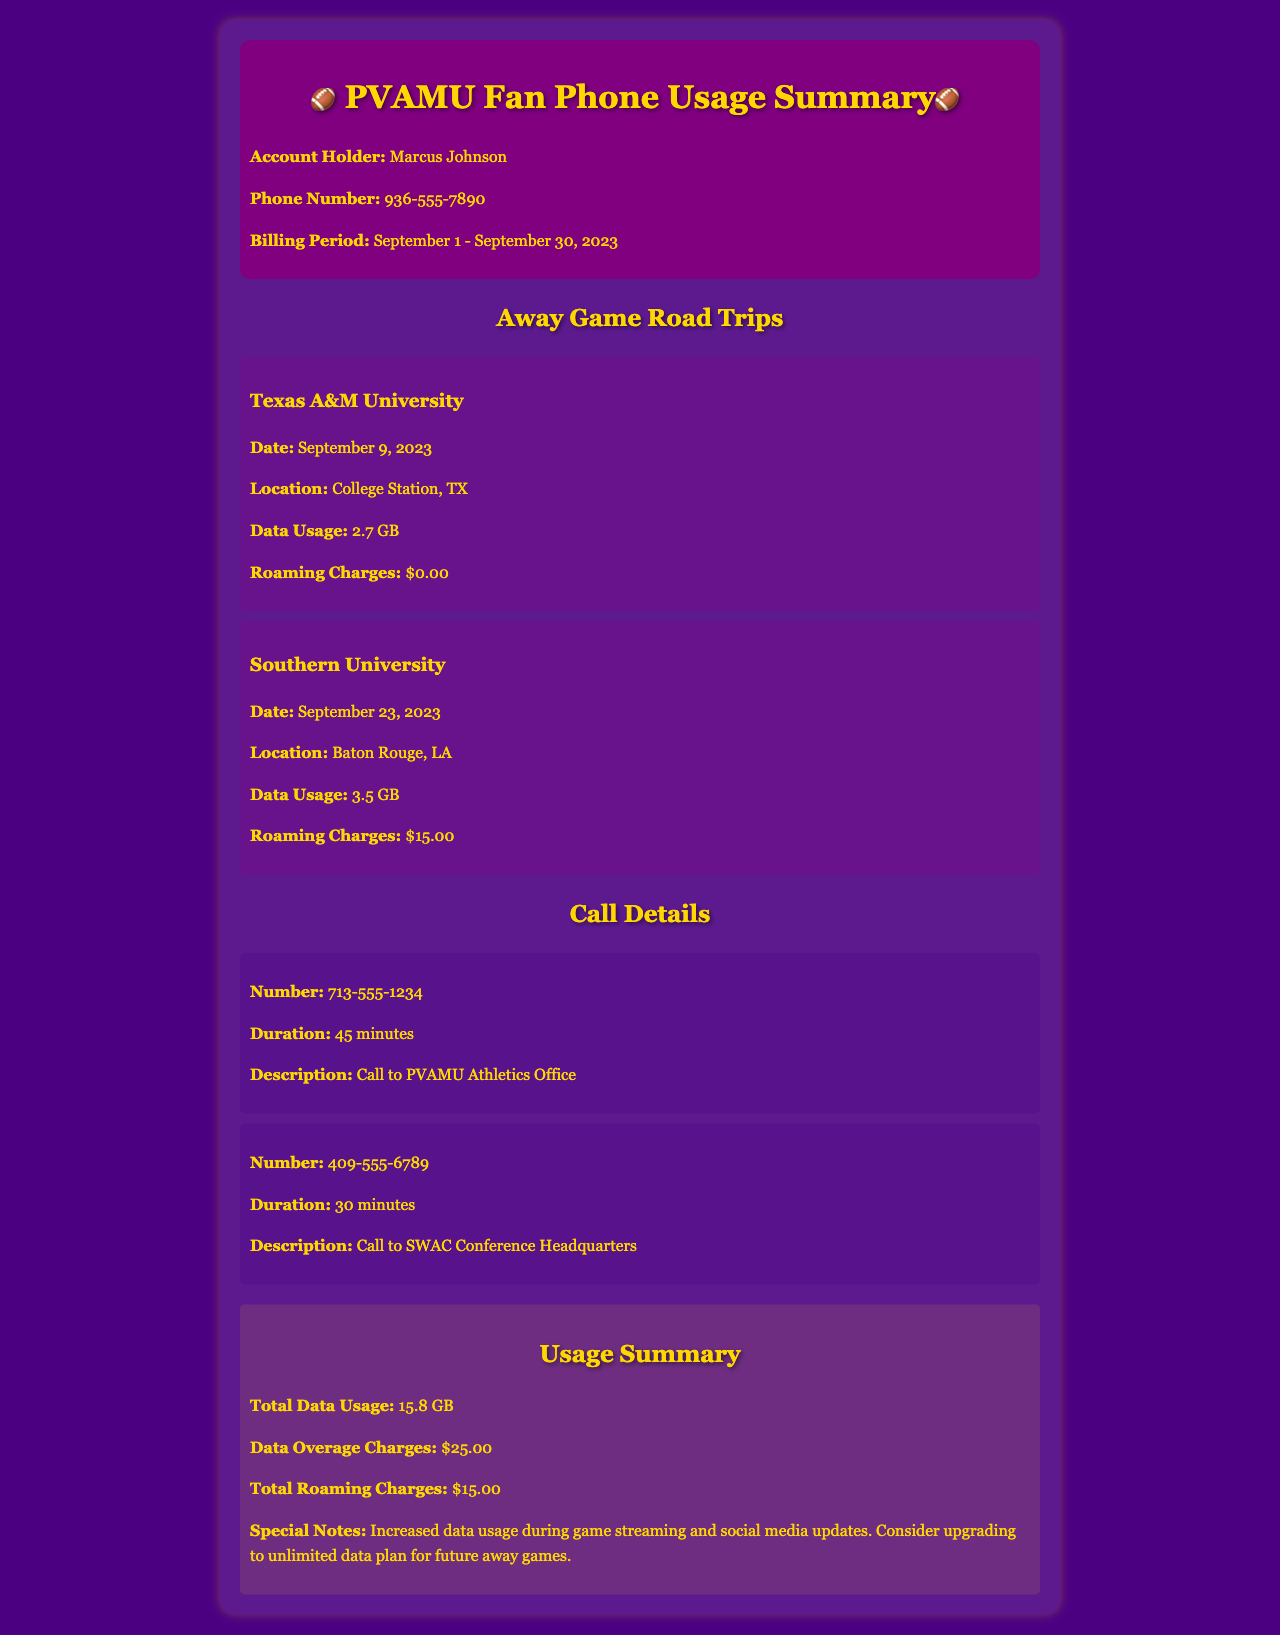What is the account holder's name? The document states the account holder's name at the beginning: Marcus Johnson.
Answer: Marcus Johnson What was the data usage during the Southern University game? The section for the Southern University game specifies the data usage as 3.5 GB.
Answer: 3.5 GB What were the roaming charges for the Texas A&M University game? The information displayed for the Texas A&M University game indicates that the roaming charges were $0.00.
Answer: $0.00 How long was the call to the SWAC Conference Headquarters? The call details section mentions that the duration of the call to SWAC Conference Headquarters was 30 minutes.
Answer: 30 minutes What is the total roaming charges listed in the usage summary? The summary section states the total roaming charges incurred during the billing period, which is $15.00.
Answer: $15.00 Which game had the highest data usage? Reviewing the data usage of both games, Southern University had the highest data usage of 3.5 GB.
Answer: Southern University What is the total data usage recorded during the billing period? The usage summary states that the total data usage is 15.8 GB.
Answer: 15.8 GB What special note is mentioned regarding data usage? The special notes section highlights increased data usage during game streaming and social media updates.
Answer: Increased data usage during game streaming and social media updates How much are the data overage charges? The summary indicates that the data overage charges amount to $25.00.
Answer: $25.00 